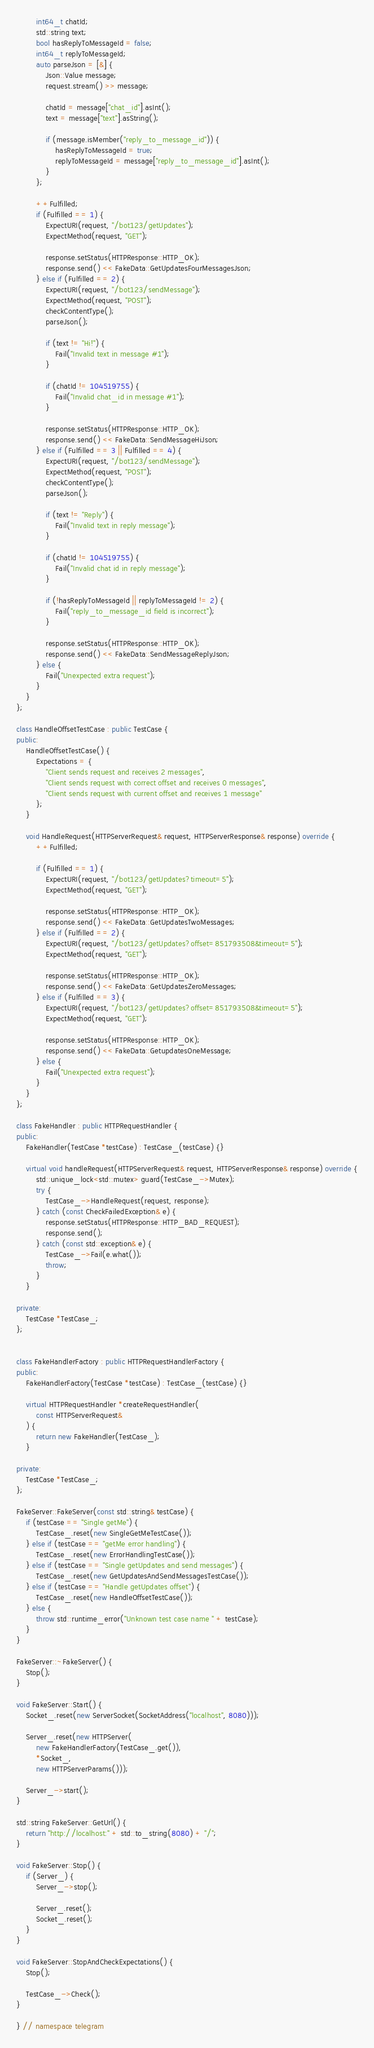Convert code to text. <code><loc_0><loc_0><loc_500><loc_500><_C++_>        int64_t chatId;
        std::string text;
        bool hasReplyToMessageId = false;
        int64_t replyToMessageId;
        auto parseJson = [&] {
            Json::Value message;
            request.stream() >> message;

            chatId = message["chat_id"].asInt();
            text = message["text"].asString();

            if (message.isMember("reply_to_message_id")) {
                hasReplyToMessageId = true;
                replyToMessageId = message["reply_to_message_id"].asInt();
            }
        };

        ++Fulfilled;
        if (Fulfilled == 1) {
            ExpectURI(request, "/bot123/getUpdates");
            ExpectMethod(request, "GET");

            response.setStatus(HTTPResponse::HTTP_OK);
            response.send() << FakeData::GetUpdatesFourMessagesJson;
        } else if (Fulfilled == 2) {
            ExpectURI(request, "/bot123/sendMessage");
            ExpectMethod(request, "POST");
            checkContentType();
            parseJson();

            if (text != "Hi!") {
                Fail("Invalid text in message #1");
            }

            if (chatId != 104519755) {
                Fail("Invalid chat_id in message #1");
            }

            response.setStatus(HTTPResponse::HTTP_OK);
            response.send() << FakeData::SendMessageHiJson;
        } else if (Fulfilled == 3 || Fulfilled == 4) {
            ExpectURI(request, "/bot123/sendMessage");
            ExpectMethod(request, "POST");
            checkContentType();
            parseJson();

            if (text != "Reply") {
                Fail("Invalid text in reply message");
            }

            if (chatId != 104519755) {
                Fail("Invalid chat id in reply message");
            }

            if (!hasReplyToMessageId || replyToMessageId != 2) {
                Fail("reply_to_message_id field is incorrect");
            }

            response.setStatus(HTTPResponse::HTTP_OK);
            response.send() << FakeData::SendMessageReplyJson;
        } else {
            Fail("Unexpected extra request");
        }
    }
};

class HandleOffsetTestCase : public TestCase {
public:
    HandleOffsetTestCase() {
        Expectations = {
            "Client sends request and receives 2 messages",
            "Client sends request with correct offset and receives 0 messages",
            "Client sends request with current offset and receives 1 message"
        };
    }

    void HandleRequest(HTTPServerRequest& request, HTTPServerResponse& response) override {
        ++Fulfilled;

        if (Fulfilled == 1) {
            ExpectURI(request, "/bot123/getUpdates?timeout=5");
            ExpectMethod(request, "GET");

            response.setStatus(HTTPResponse::HTTP_OK);
            response.send() << FakeData::GetUpdatesTwoMessages;
        } else if (Fulfilled == 2) {
            ExpectURI(request, "/bot123/getUpdates?offset=851793508&timeout=5");
            ExpectMethod(request, "GET");

            response.setStatus(HTTPResponse::HTTP_OK);
            response.send() << FakeData::GetUpdatesZeroMessages;
        } else if (Fulfilled == 3) {
            ExpectURI(request, "/bot123/getUpdates?offset=851793508&timeout=5");
            ExpectMethod(request, "GET");

            response.setStatus(HTTPResponse::HTTP_OK);
            response.send() << FakeData::GetupdatesOneMessage;
        } else {
            Fail("Unexpected extra request");
        }
    }
};

class FakeHandler : public HTTPRequestHandler {
public:
    FakeHandler(TestCase *testCase) : TestCase_(testCase) {}

    virtual void handleRequest(HTTPServerRequest& request, HTTPServerResponse& response) override {
        std::unique_lock<std::mutex> guard(TestCase_->Mutex);
        try {
            TestCase_->HandleRequest(request, response);
        } catch (const CheckFailedException& e) {
            response.setStatus(HTTPResponse::HTTP_BAD_REQUEST);
            response.send();
        } catch (const std::exception& e) {
            TestCase_->Fail(e.what());
            throw;
        }
    }

private:
    TestCase *TestCase_;
};


class FakeHandlerFactory : public HTTPRequestHandlerFactory {
public:
    FakeHandlerFactory(TestCase *testCase) : TestCase_(testCase) {}

    virtual HTTPRequestHandler *createRequestHandler(
        const HTTPServerRequest&
    ) {
        return new FakeHandler(TestCase_);
    }

private:
    TestCase *TestCase_;
};

FakeServer::FakeServer(const std::string& testCase) {
    if (testCase == "Single getMe") {
        TestCase_.reset(new SingleGetMeTestCase());
    } else if (testCase == "getMe error handling") {
        TestCase_.reset(new ErrorHandlingTestCase());
    } else if (testCase == "Single getUpdates and send messages") {
        TestCase_.reset(new GetUpdatesAndSendMessagesTestCase());
    } else if (testCase == "Handle getUpdates offset") {
        TestCase_.reset(new HandleOffsetTestCase());
    } else {
        throw std::runtime_error("Unknown test case name " + testCase);
    }
}

FakeServer::~FakeServer() {
    Stop();
}

void FakeServer::Start() {
    Socket_.reset(new ServerSocket(SocketAddress("localhost", 8080)));

    Server_.reset(new HTTPServer(
        new FakeHandlerFactory(TestCase_.get()),
        *Socket_,
        new HTTPServerParams()));

    Server_->start();
}

std::string FakeServer::GetUrl() {
    return "http://localhost:" + std::to_string(8080) + "/";
}

void FakeServer::Stop() {
    if (Server_) {
        Server_->stop();

        Server_.reset();
        Socket_.reset();
    }
}

void FakeServer::StopAndCheckExpectations() {
    Stop();

    TestCase_->Check();
}

} // namespace telegram
</code> 